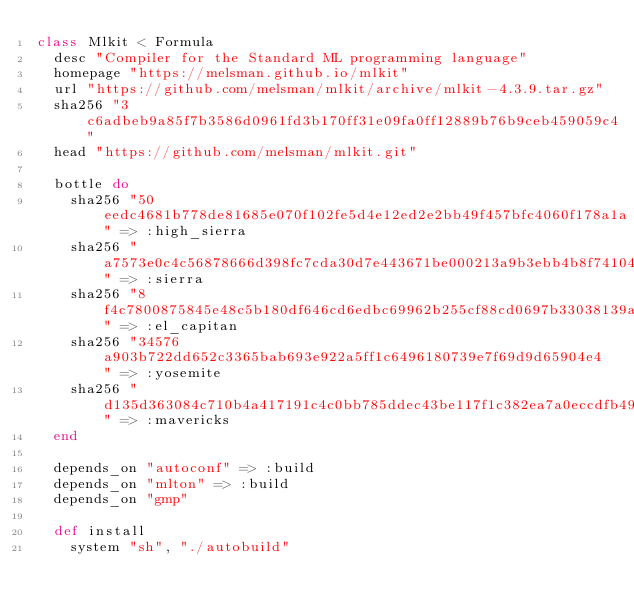Convert code to text. <code><loc_0><loc_0><loc_500><loc_500><_Ruby_>class Mlkit < Formula
  desc "Compiler for the Standard ML programming language"
  homepage "https://melsman.github.io/mlkit"
  url "https://github.com/melsman/mlkit/archive/mlkit-4.3.9.tar.gz"
  sha256 "3c6adbeb9a85f7b3586d0961fd3b170ff31e09fa0ff12889b76b9ceb459059c4"
  head "https://github.com/melsman/mlkit.git"

  bottle do
    sha256 "50eedc4681b778de81685e070f102fe5d4e12ed2e2bb49f457bfc4060f178a1a" => :high_sierra
    sha256 "a7573e0c4c56878666d398fc7cda30d7e443671be000213a9b3ebb4b8f741041" => :sierra
    sha256 "8f4c7800875845e48c5b180df646cd6edbc69962b255cf88cd0697b33038139a" => :el_capitan
    sha256 "34576a903b722dd652c3365bab693e922a5ff1c6496180739e7f69d9d65904e4" => :yosemite
    sha256 "d135d363084c710b4a417191c4c0bb785ddec43be117f1c382ea7a0eccdfb49a" => :mavericks
  end

  depends_on "autoconf" => :build
  depends_on "mlton" => :build
  depends_on "gmp"

  def install
    system "sh", "./autobuild"</code> 